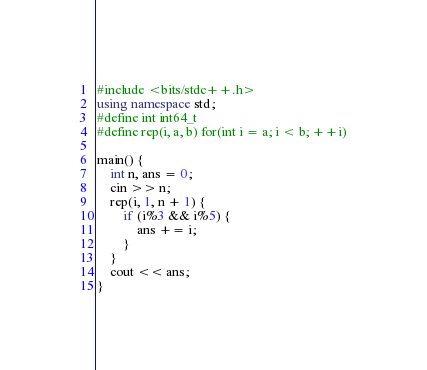Convert code to text. <code><loc_0><loc_0><loc_500><loc_500><_C++_>#include <bits/stdc++.h>
using namespace std;
#define int int64_t
#define rep(i, a, b) for(int i = a; i < b; ++i)

main() {
    int n, ans = 0;
    cin >> n;
    rep(i, 1, n + 1) {
        if (i%3 && i%5) {
            ans += i;
        }
    }
    cout << ans;
}</code> 